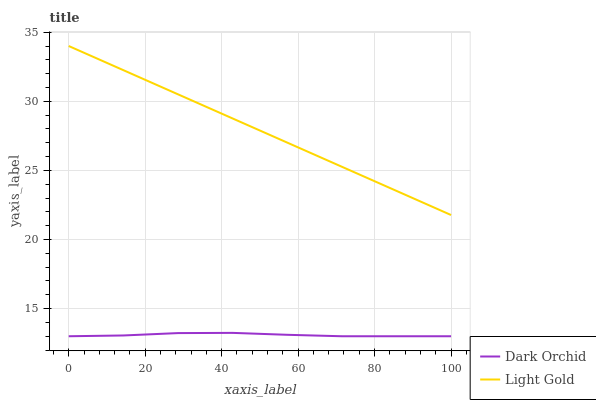Does Dark Orchid have the minimum area under the curve?
Answer yes or no. Yes. Does Light Gold have the maximum area under the curve?
Answer yes or no. Yes. Does Dark Orchid have the maximum area under the curve?
Answer yes or no. No. Is Light Gold the smoothest?
Answer yes or no. Yes. Is Dark Orchid the roughest?
Answer yes or no. Yes. Is Dark Orchid the smoothest?
Answer yes or no. No. Does Dark Orchid have the lowest value?
Answer yes or no. Yes. Does Light Gold have the highest value?
Answer yes or no. Yes. Does Dark Orchid have the highest value?
Answer yes or no. No. Is Dark Orchid less than Light Gold?
Answer yes or no. Yes. Is Light Gold greater than Dark Orchid?
Answer yes or no. Yes. Does Dark Orchid intersect Light Gold?
Answer yes or no. No. 